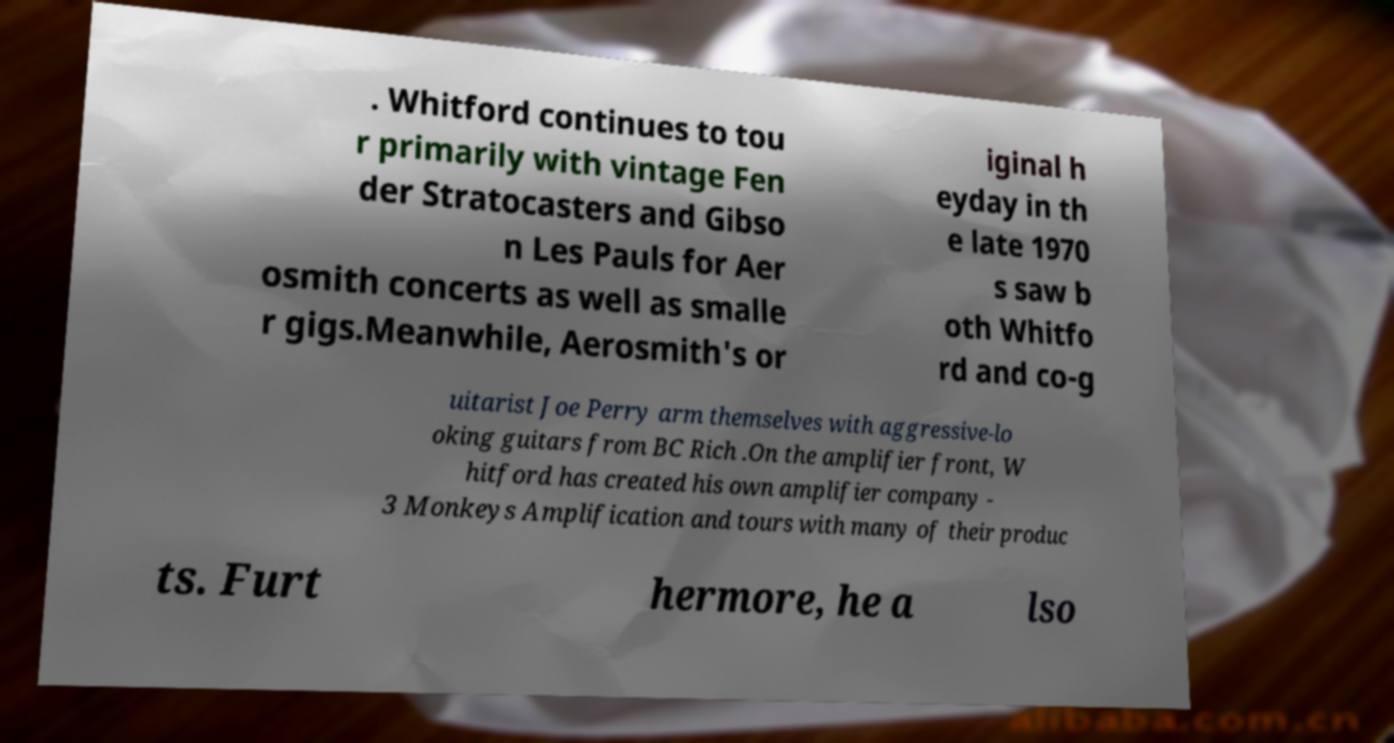There's text embedded in this image that I need extracted. Can you transcribe it verbatim? . Whitford continues to tou r primarily with vintage Fen der Stratocasters and Gibso n Les Pauls for Aer osmith concerts as well as smalle r gigs.Meanwhile, Aerosmith's or iginal h eyday in th e late 1970 s saw b oth Whitfo rd and co-g uitarist Joe Perry arm themselves with aggressive-lo oking guitars from BC Rich .On the amplifier front, W hitford has created his own amplifier company - 3 Monkeys Amplification and tours with many of their produc ts. Furt hermore, he a lso 